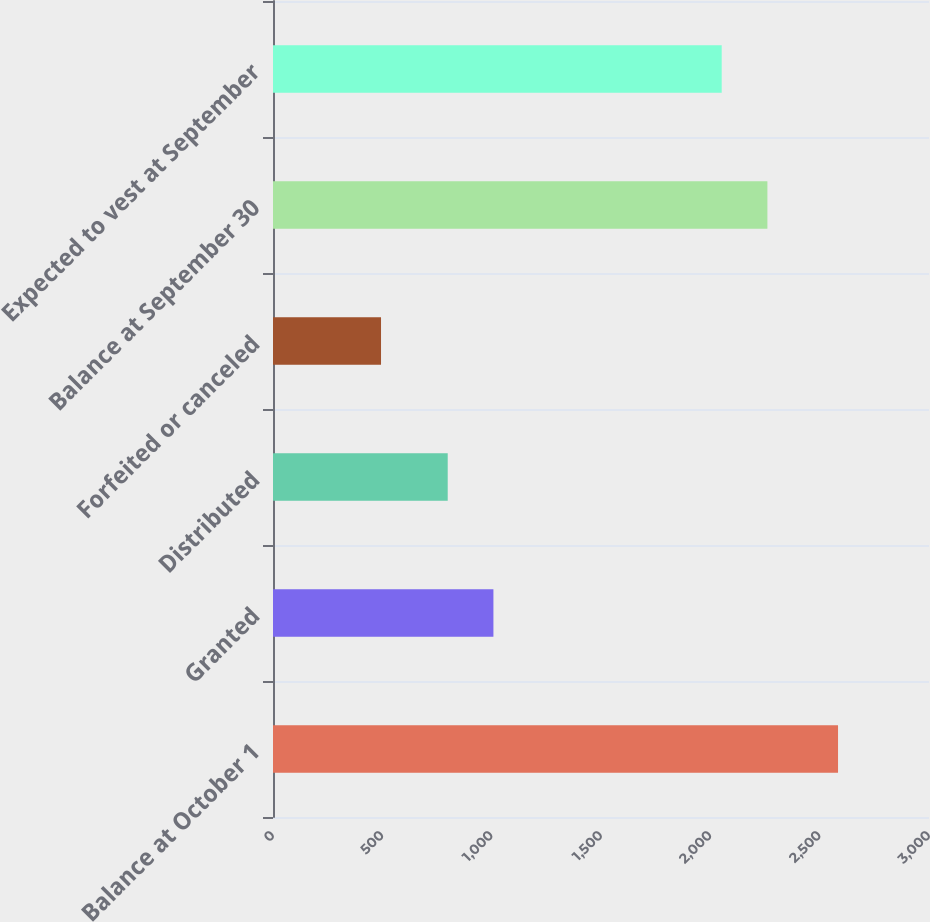<chart> <loc_0><loc_0><loc_500><loc_500><bar_chart><fcel>Balance at October 1<fcel>Granted<fcel>Distributed<fcel>Forfeited or canceled<fcel>Balance at September 30<fcel>Expected to vest at September<nl><fcel>2584<fcel>1008<fcel>799<fcel>494<fcel>2261<fcel>2052<nl></chart> 